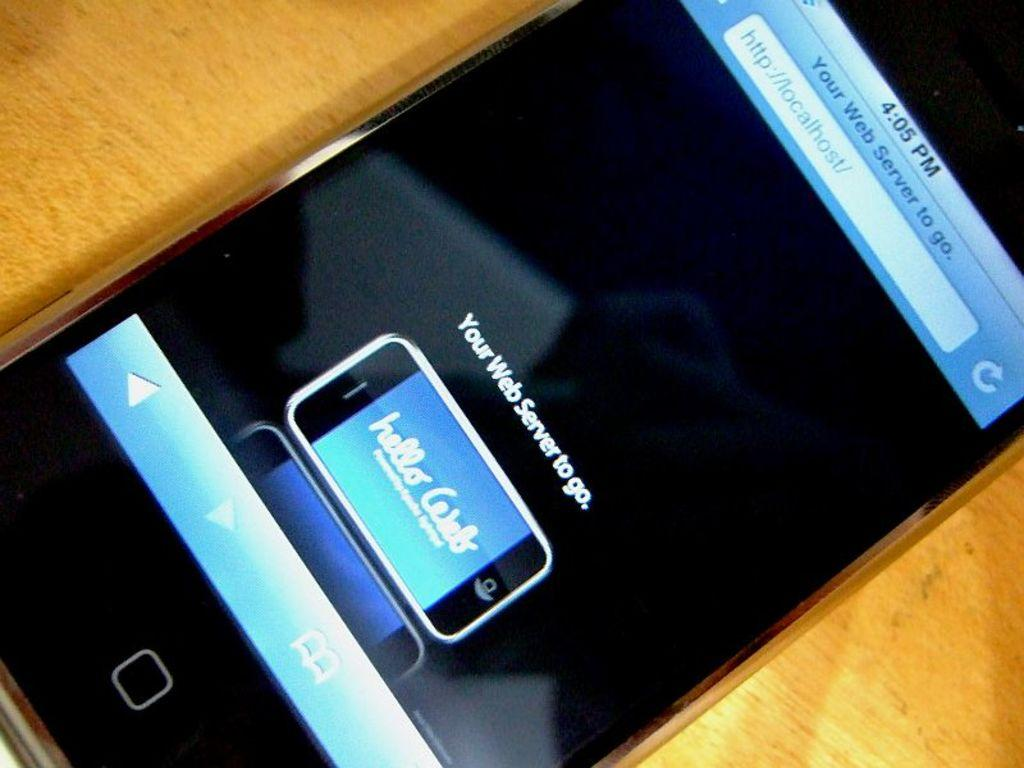<image>
Present a compact description of the photo's key features. A Hello Web advertisement is displayed on a smartphone screen. 